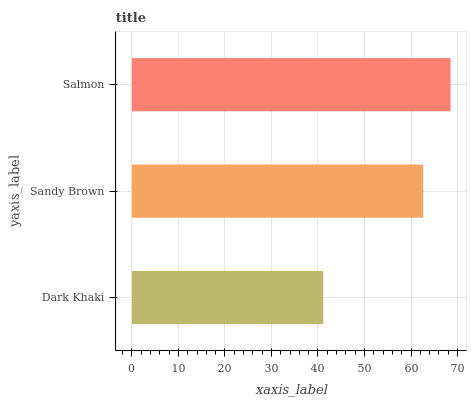Is Dark Khaki the minimum?
Answer yes or no. Yes. Is Salmon the maximum?
Answer yes or no. Yes. Is Sandy Brown the minimum?
Answer yes or no. No. Is Sandy Brown the maximum?
Answer yes or no. No. Is Sandy Brown greater than Dark Khaki?
Answer yes or no. Yes. Is Dark Khaki less than Sandy Brown?
Answer yes or no. Yes. Is Dark Khaki greater than Sandy Brown?
Answer yes or no. No. Is Sandy Brown less than Dark Khaki?
Answer yes or no. No. Is Sandy Brown the high median?
Answer yes or no. Yes. Is Sandy Brown the low median?
Answer yes or no. Yes. Is Dark Khaki the high median?
Answer yes or no. No. Is Dark Khaki the low median?
Answer yes or no. No. 